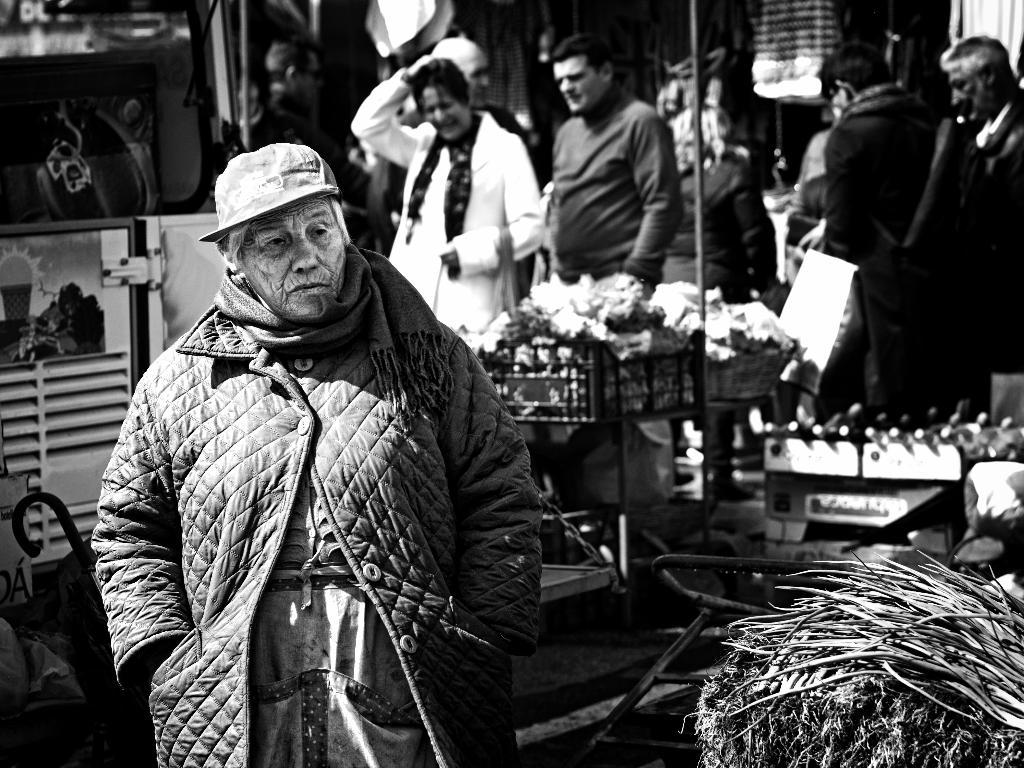What is the color scheme of the image? The image is black and white. What can be seen in the image in terms of people? There is a group of people standing in the image. What else is present in the image besides people? There is a vehicle and some objects in the image. Is there any quicksand visible in the image? No, there is no quicksand present in the image. What type of string is being used by the people in the image? There is no string visible in the image. 